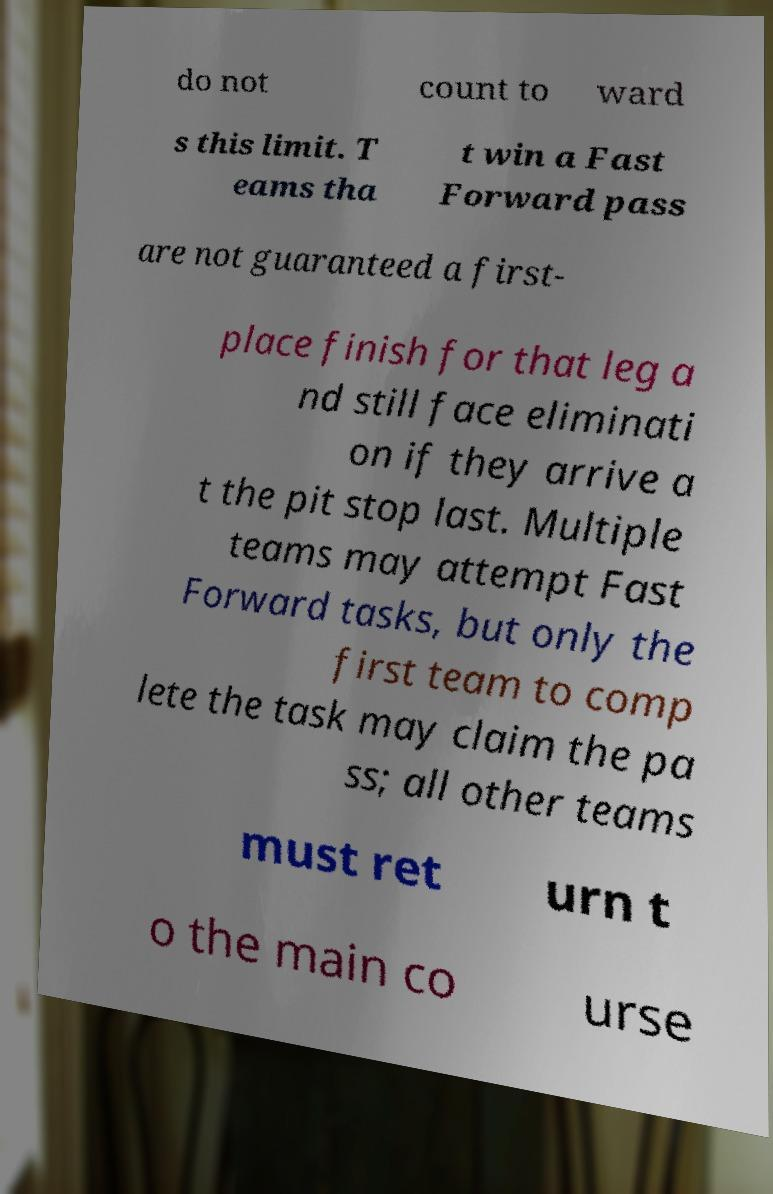I need the written content from this picture converted into text. Can you do that? do not count to ward s this limit. T eams tha t win a Fast Forward pass are not guaranteed a first- place finish for that leg a nd still face eliminati on if they arrive a t the pit stop last. Multiple teams may attempt Fast Forward tasks, but only the first team to comp lete the task may claim the pa ss; all other teams must ret urn t o the main co urse 